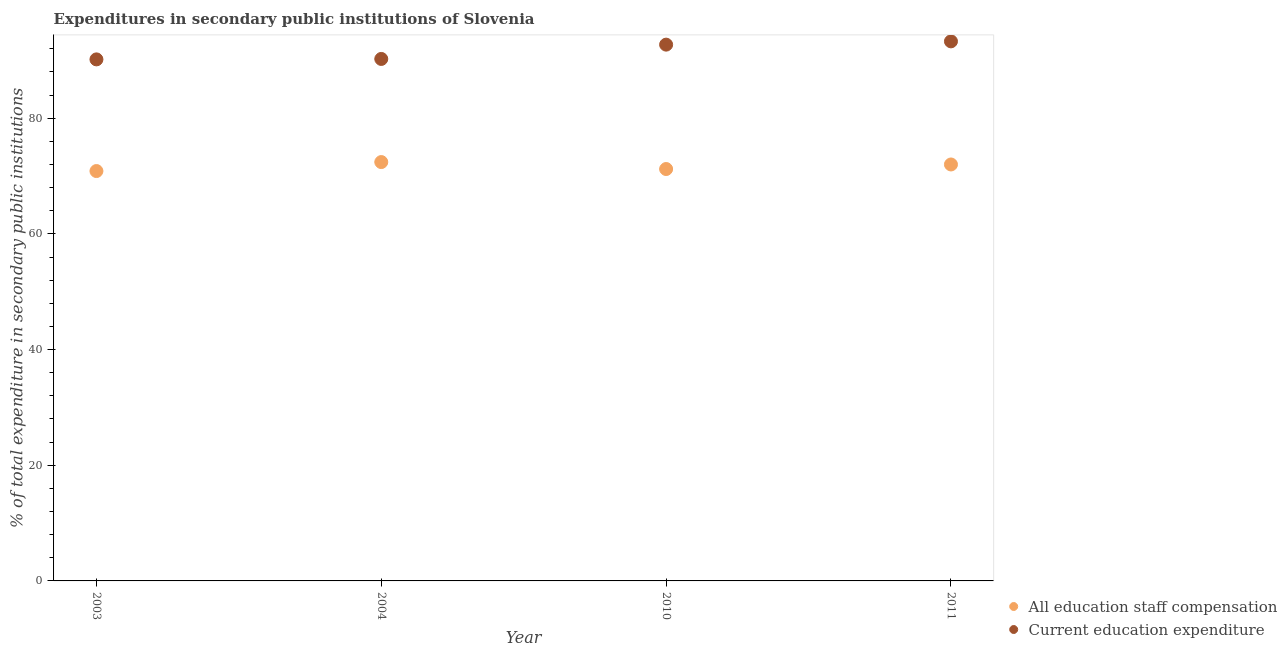What is the expenditure in education in 2011?
Offer a very short reply. 93.3. Across all years, what is the maximum expenditure in education?
Your answer should be very brief. 93.3. Across all years, what is the minimum expenditure in staff compensation?
Make the answer very short. 70.87. In which year was the expenditure in staff compensation maximum?
Your response must be concise. 2004. What is the total expenditure in education in the graph?
Keep it short and to the point. 366.46. What is the difference between the expenditure in education in 2003 and that in 2011?
Keep it short and to the point. -3.12. What is the difference between the expenditure in education in 2011 and the expenditure in staff compensation in 2003?
Your answer should be very brief. 22.42. What is the average expenditure in staff compensation per year?
Provide a short and direct response. 71.63. In the year 2003, what is the difference between the expenditure in education and expenditure in staff compensation?
Keep it short and to the point. 19.31. What is the ratio of the expenditure in education in 2003 to that in 2004?
Offer a terse response. 1. Is the expenditure in staff compensation in 2010 less than that in 2011?
Provide a short and direct response. Yes. What is the difference between the highest and the second highest expenditure in staff compensation?
Your answer should be very brief. 0.42. What is the difference between the highest and the lowest expenditure in staff compensation?
Your answer should be very brief. 1.55. In how many years, is the expenditure in staff compensation greater than the average expenditure in staff compensation taken over all years?
Give a very brief answer. 2. Is the sum of the expenditure in staff compensation in 2003 and 2010 greater than the maximum expenditure in education across all years?
Your response must be concise. Yes. Does the expenditure in staff compensation monotonically increase over the years?
Offer a terse response. No. Is the expenditure in staff compensation strictly greater than the expenditure in education over the years?
Keep it short and to the point. No. How many dotlines are there?
Provide a short and direct response. 2. Does the graph contain grids?
Your response must be concise. No. What is the title of the graph?
Your response must be concise. Expenditures in secondary public institutions of Slovenia. What is the label or title of the X-axis?
Offer a very short reply. Year. What is the label or title of the Y-axis?
Provide a short and direct response. % of total expenditure in secondary public institutions. What is the % of total expenditure in secondary public institutions in All education staff compensation in 2003?
Ensure brevity in your answer.  70.87. What is the % of total expenditure in secondary public institutions in Current education expenditure in 2003?
Offer a terse response. 90.18. What is the % of total expenditure in secondary public institutions in All education staff compensation in 2004?
Your answer should be very brief. 72.42. What is the % of total expenditure in secondary public institutions in Current education expenditure in 2004?
Offer a terse response. 90.26. What is the % of total expenditure in secondary public institutions in All education staff compensation in 2010?
Provide a succinct answer. 71.22. What is the % of total expenditure in secondary public institutions of Current education expenditure in 2010?
Make the answer very short. 92.73. What is the % of total expenditure in secondary public institutions in All education staff compensation in 2011?
Keep it short and to the point. 72.01. What is the % of total expenditure in secondary public institutions of Current education expenditure in 2011?
Your response must be concise. 93.3. Across all years, what is the maximum % of total expenditure in secondary public institutions in All education staff compensation?
Make the answer very short. 72.42. Across all years, what is the maximum % of total expenditure in secondary public institutions in Current education expenditure?
Provide a succinct answer. 93.3. Across all years, what is the minimum % of total expenditure in secondary public institutions of All education staff compensation?
Provide a short and direct response. 70.87. Across all years, what is the minimum % of total expenditure in secondary public institutions of Current education expenditure?
Keep it short and to the point. 90.18. What is the total % of total expenditure in secondary public institutions in All education staff compensation in the graph?
Your response must be concise. 286.52. What is the total % of total expenditure in secondary public institutions in Current education expenditure in the graph?
Provide a short and direct response. 366.46. What is the difference between the % of total expenditure in secondary public institutions in All education staff compensation in 2003 and that in 2004?
Your response must be concise. -1.55. What is the difference between the % of total expenditure in secondary public institutions in Current education expenditure in 2003 and that in 2004?
Provide a succinct answer. -0.08. What is the difference between the % of total expenditure in secondary public institutions of All education staff compensation in 2003 and that in 2010?
Keep it short and to the point. -0.35. What is the difference between the % of total expenditure in secondary public institutions of Current education expenditure in 2003 and that in 2010?
Make the answer very short. -2.55. What is the difference between the % of total expenditure in secondary public institutions in All education staff compensation in 2003 and that in 2011?
Offer a very short reply. -1.14. What is the difference between the % of total expenditure in secondary public institutions in Current education expenditure in 2003 and that in 2011?
Make the answer very short. -3.12. What is the difference between the % of total expenditure in secondary public institutions of All education staff compensation in 2004 and that in 2010?
Provide a succinct answer. 1.2. What is the difference between the % of total expenditure in secondary public institutions in Current education expenditure in 2004 and that in 2010?
Provide a succinct answer. -2.47. What is the difference between the % of total expenditure in secondary public institutions of All education staff compensation in 2004 and that in 2011?
Give a very brief answer. 0.42. What is the difference between the % of total expenditure in secondary public institutions of Current education expenditure in 2004 and that in 2011?
Provide a short and direct response. -3.04. What is the difference between the % of total expenditure in secondary public institutions of All education staff compensation in 2010 and that in 2011?
Make the answer very short. -0.79. What is the difference between the % of total expenditure in secondary public institutions of Current education expenditure in 2010 and that in 2011?
Keep it short and to the point. -0.57. What is the difference between the % of total expenditure in secondary public institutions in All education staff compensation in 2003 and the % of total expenditure in secondary public institutions in Current education expenditure in 2004?
Your answer should be very brief. -19.38. What is the difference between the % of total expenditure in secondary public institutions of All education staff compensation in 2003 and the % of total expenditure in secondary public institutions of Current education expenditure in 2010?
Your answer should be very brief. -21.86. What is the difference between the % of total expenditure in secondary public institutions of All education staff compensation in 2003 and the % of total expenditure in secondary public institutions of Current education expenditure in 2011?
Your answer should be compact. -22.42. What is the difference between the % of total expenditure in secondary public institutions of All education staff compensation in 2004 and the % of total expenditure in secondary public institutions of Current education expenditure in 2010?
Keep it short and to the point. -20.3. What is the difference between the % of total expenditure in secondary public institutions of All education staff compensation in 2004 and the % of total expenditure in secondary public institutions of Current education expenditure in 2011?
Your answer should be compact. -20.87. What is the difference between the % of total expenditure in secondary public institutions in All education staff compensation in 2010 and the % of total expenditure in secondary public institutions in Current education expenditure in 2011?
Your answer should be very brief. -22.07. What is the average % of total expenditure in secondary public institutions of All education staff compensation per year?
Give a very brief answer. 71.63. What is the average % of total expenditure in secondary public institutions of Current education expenditure per year?
Ensure brevity in your answer.  91.61. In the year 2003, what is the difference between the % of total expenditure in secondary public institutions of All education staff compensation and % of total expenditure in secondary public institutions of Current education expenditure?
Provide a short and direct response. -19.31. In the year 2004, what is the difference between the % of total expenditure in secondary public institutions in All education staff compensation and % of total expenditure in secondary public institutions in Current education expenditure?
Offer a terse response. -17.83. In the year 2010, what is the difference between the % of total expenditure in secondary public institutions in All education staff compensation and % of total expenditure in secondary public institutions in Current education expenditure?
Ensure brevity in your answer.  -21.51. In the year 2011, what is the difference between the % of total expenditure in secondary public institutions of All education staff compensation and % of total expenditure in secondary public institutions of Current education expenditure?
Offer a terse response. -21.29. What is the ratio of the % of total expenditure in secondary public institutions in All education staff compensation in 2003 to that in 2004?
Your answer should be compact. 0.98. What is the ratio of the % of total expenditure in secondary public institutions in Current education expenditure in 2003 to that in 2010?
Offer a terse response. 0.97. What is the ratio of the % of total expenditure in secondary public institutions in All education staff compensation in 2003 to that in 2011?
Your answer should be very brief. 0.98. What is the ratio of the % of total expenditure in secondary public institutions of Current education expenditure in 2003 to that in 2011?
Offer a very short reply. 0.97. What is the ratio of the % of total expenditure in secondary public institutions in All education staff compensation in 2004 to that in 2010?
Your response must be concise. 1.02. What is the ratio of the % of total expenditure in secondary public institutions of Current education expenditure in 2004 to that in 2010?
Give a very brief answer. 0.97. What is the ratio of the % of total expenditure in secondary public institutions in All education staff compensation in 2004 to that in 2011?
Offer a very short reply. 1.01. What is the ratio of the % of total expenditure in secondary public institutions in Current education expenditure in 2004 to that in 2011?
Your answer should be compact. 0.97. What is the ratio of the % of total expenditure in secondary public institutions of All education staff compensation in 2010 to that in 2011?
Make the answer very short. 0.99. What is the difference between the highest and the second highest % of total expenditure in secondary public institutions of All education staff compensation?
Make the answer very short. 0.42. What is the difference between the highest and the second highest % of total expenditure in secondary public institutions of Current education expenditure?
Your answer should be very brief. 0.57. What is the difference between the highest and the lowest % of total expenditure in secondary public institutions of All education staff compensation?
Ensure brevity in your answer.  1.55. What is the difference between the highest and the lowest % of total expenditure in secondary public institutions in Current education expenditure?
Your answer should be compact. 3.12. 